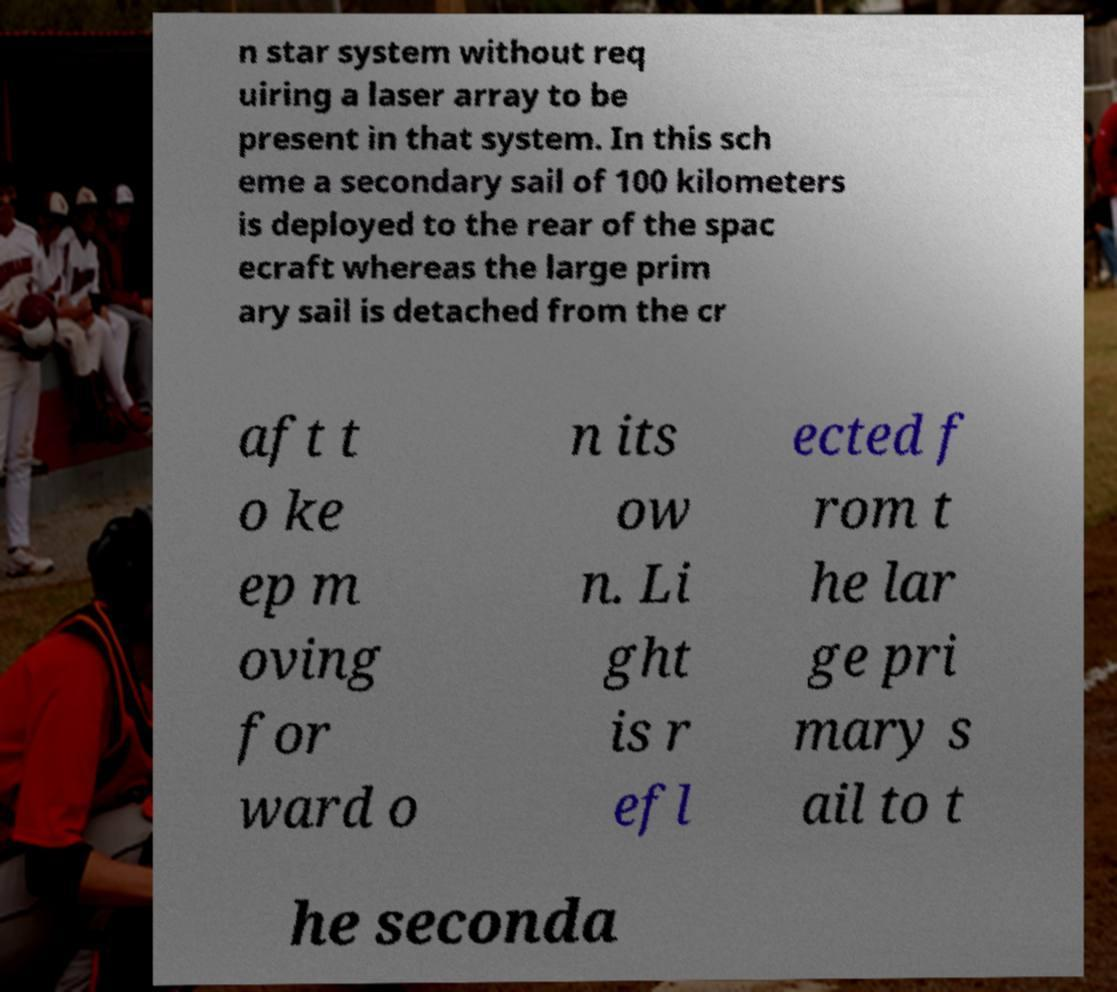Could you assist in decoding the text presented in this image and type it out clearly? n star system without req uiring a laser array to be present in that system. In this sch eme a secondary sail of 100 kilometers is deployed to the rear of the spac ecraft whereas the large prim ary sail is detached from the cr aft t o ke ep m oving for ward o n its ow n. Li ght is r efl ected f rom t he lar ge pri mary s ail to t he seconda 